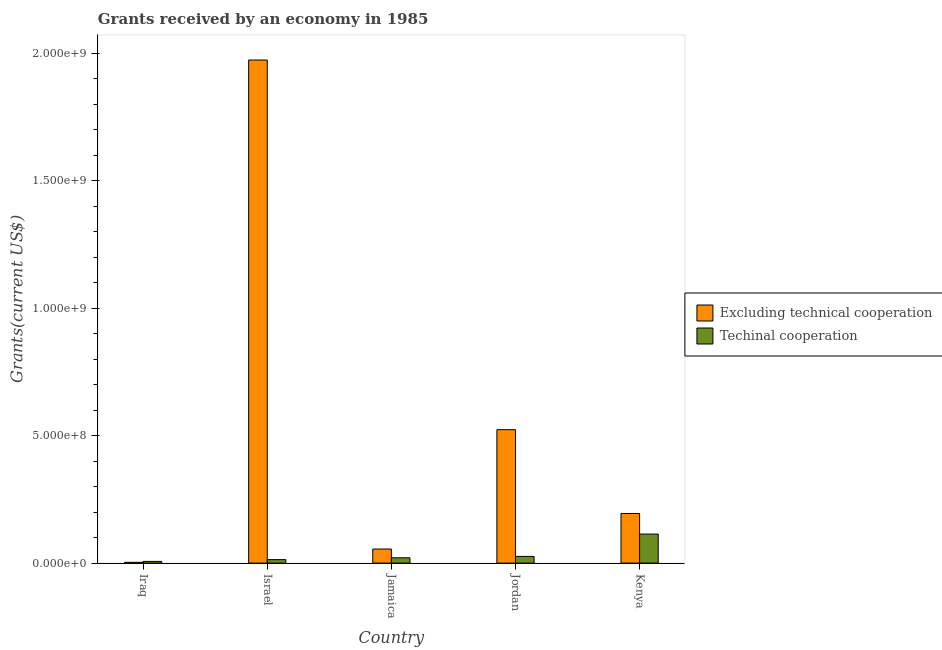How many different coloured bars are there?
Give a very brief answer. 2. What is the label of the 3rd group of bars from the left?
Make the answer very short. Jamaica. In how many cases, is the number of bars for a given country not equal to the number of legend labels?
Offer a terse response. 0. What is the amount of grants received(excluding technical cooperation) in Iraq?
Your answer should be compact. 3.13e+06. Across all countries, what is the maximum amount of grants received(excluding technical cooperation)?
Keep it short and to the point. 1.97e+09. Across all countries, what is the minimum amount of grants received(including technical cooperation)?
Provide a short and direct response. 6.67e+06. In which country was the amount of grants received(including technical cooperation) maximum?
Offer a terse response. Kenya. In which country was the amount of grants received(including technical cooperation) minimum?
Your answer should be compact. Iraq. What is the total amount of grants received(including technical cooperation) in the graph?
Make the answer very short. 1.81e+08. What is the difference between the amount of grants received(excluding technical cooperation) in Israel and that in Jordan?
Give a very brief answer. 1.45e+09. What is the difference between the amount of grants received(including technical cooperation) in Iraq and the amount of grants received(excluding technical cooperation) in Jordan?
Give a very brief answer. -5.17e+08. What is the average amount of grants received(including technical cooperation) per country?
Your response must be concise. 3.62e+07. What is the difference between the amount of grants received(including technical cooperation) and amount of grants received(excluding technical cooperation) in Jamaica?
Your answer should be compact. -3.43e+07. What is the ratio of the amount of grants received(excluding technical cooperation) in Jordan to that in Kenya?
Provide a succinct answer. 2.69. What is the difference between the highest and the second highest amount of grants received(including technical cooperation)?
Provide a short and direct response. 8.76e+07. What is the difference between the highest and the lowest amount of grants received(including technical cooperation)?
Offer a terse response. 1.07e+08. Is the sum of the amount of grants received(excluding technical cooperation) in Iraq and Israel greater than the maximum amount of grants received(including technical cooperation) across all countries?
Offer a very short reply. Yes. What does the 2nd bar from the left in Jamaica represents?
Keep it short and to the point. Techinal cooperation. What does the 1st bar from the right in Jordan represents?
Your answer should be compact. Techinal cooperation. What is the difference between two consecutive major ticks on the Y-axis?
Give a very brief answer. 5.00e+08. Are the values on the major ticks of Y-axis written in scientific E-notation?
Offer a very short reply. Yes. Does the graph contain grids?
Provide a succinct answer. No. How are the legend labels stacked?
Offer a very short reply. Vertical. What is the title of the graph?
Provide a succinct answer. Grants received by an economy in 1985. What is the label or title of the X-axis?
Your answer should be compact. Country. What is the label or title of the Y-axis?
Your response must be concise. Grants(current US$). What is the Grants(current US$) of Excluding technical cooperation in Iraq?
Offer a very short reply. 3.13e+06. What is the Grants(current US$) in Techinal cooperation in Iraq?
Give a very brief answer. 6.67e+06. What is the Grants(current US$) of Excluding technical cooperation in Israel?
Provide a succinct answer. 1.97e+09. What is the Grants(current US$) in Techinal cooperation in Israel?
Give a very brief answer. 1.36e+07. What is the Grants(current US$) in Excluding technical cooperation in Jamaica?
Give a very brief answer. 5.51e+07. What is the Grants(current US$) of Techinal cooperation in Jamaica?
Your answer should be very brief. 2.08e+07. What is the Grants(current US$) of Excluding technical cooperation in Jordan?
Keep it short and to the point. 5.23e+08. What is the Grants(current US$) of Techinal cooperation in Jordan?
Your answer should be very brief. 2.62e+07. What is the Grants(current US$) of Excluding technical cooperation in Kenya?
Offer a terse response. 1.95e+08. What is the Grants(current US$) in Techinal cooperation in Kenya?
Make the answer very short. 1.14e+08. Across all countries, what is the maximum Grants(current US$) of Excluding technical cooperation?
Your answer should be very brief. 1.97e+09. Across all countries, what is the maximum Grants(current US$) in Techinal cooperation?
Provide a succinct answer. 1.14e+08. Across all countries, what is the minimum Grants(current US$) in Excluding technical cooperation?
Ensure brevity in your answer.  3.13e+06. Across all countries, what is the minimum Grants(current US$) in Techinal cooperation?
Offer a very short reply. 6.67e+06. What is the total Grants(current US$) in Excluding technical cooperation in the graph?
Offer a terse response. 2.75e+09. What is the total Grants(current US$) in Techinal cooperation in the graph?
Keep it short and to the point. 1.81e+08. What is the difference between the Grants(current US$) of Excluding technical cooperation in Iraq and that in Israel?
Ensure brevity in your answer.  -1.97e+09. What is the difference between the Grants(current US$) in Techinal cooperation in Iraq and that in Israel?
Offer a very short reply. -6.94e+06. What is the difference between the Grants(current US$) of Excluding technical cooperation in Iraq and that in Jamaica?
Provide a short and direct response. -5.20e+07. What is the difference between the Grants(current US$) of Techinal cooperation in Iraq and that in Jamaica?
Make the answer very short. -1.41e+07. What is the difference between the Grants(current US$) of Excluding technical cooperation in Iraq and that in Jordan?
Keep it short and to the point. -5.20e+08. What is the difference between the Grants(current US$) in Techinal cooperation in Iraq and that in Jordan?
Your answer should be very brief. -1.95e+07. What is the difference between the Grants(current US$) of Excluding technical cooperation in Iraq and that in Kenya?
Your answer should be very brief. -1.91e+08. What is the difference between the Grants(current US$) in Techinal cooperation in Iraq and that in Kenya?
Give a very brief answer. -1.07e+08. What is the difference between the Grants(current US$) in Excluding technical cooperation in Israel and that in Jamaica?
Ensure brevity in your answer.  1.92e+09. What is the difference between the Grants(current US$) of Techinal cooperation in Israel and that in Jamaica?
Your response must be concise. -7.19e+06. What is the difference between the Grants(current US$) of Excluding technical cooperation in Israel and that in Jordan?
Give a very brief answer. 1.45e+09. What is the difference between the Grants(current US$) in Techinal cooperation in Israel and that in Jordan?
Give a very brief answer. -1.26e+07. What is the difference between the Grants(current US$) of Excluding technical cooperation in Israel and that in Kenya?
Give a very brief answer. 1.78e+09. What is the difference between the Grants(current US$) in Techinal cooperation in Israel and that in Kenya?
Keep it short and to the point. -1.00e+08. What is the difference between the Grants(current US$) in Excluding technical cooperation in Jamaica and that in Jordan?
Provide a short and direct response. -4.68e+08. What is the difference between the Grants(current US$) of Techinal cooperation in Jamaica and that in Jordan?
Offer a very short reply. -5.40e+06. What is the difference between the Grants(current US$) of Excluding technical cooperation in Jamaica and that in Kenya?
Offer a terse response. -1.39e+08. What is the difference between the Grants(current US$) in Techinal cooperation in Jamaica and that in Kenya?
Give a very brief answer. -9.30e+07. What is the difference between the Grants(current US$) in Excluding technical cooperation in Jordan and that in Kenya?
Your answer should be very brief. 3.29e+08. What is the difference between the Grants(current US$) of Techinal cooperation in Jordan and that in Kenya?
Your answer should be very brief. -8.76e+07. What is the difference between the Grants(current US$) of Excluding technical cooperation in Iraq and the Grants(current US$) of Techinal cooperation in Israel?
Give a very brief answer. -1.05e+07. What is the difference between the Grants(current US$) of Excluding technical cooperation in Iraq and the Grants(current US$) of Techinal cooperation in Jamaica?
Your answer should be very brief. -1.77e+07. What is the difference between the Grants(current US$) in Excluding technical cooperation in Iraq and the Grants(current US$) in Techinal cooperation in Jordan?
Your response must be concise. -2.31e+07. What is the difference between the Grants(current US$) in Excluding technical cooperation in Iraq and the Grants(current US$) in Techinal cooperation in Kenya?
Provide a succinct answer. -1.11e+08. What is the difference between the Grants(current US$) in Excluding technical cooperation in Israel and the Grants(current US$) in Techinal cooperation in Jamaica?
Offer a terse response. 1.95e+09. What is the difference between the Grants(current US$) of Excluding technical cooperation in Israel and the Grants(current US$) of Techinal cooperation in Jordan?
Offer a terse response. 1.95e+09. What is the difference between the Grants(current US$) of Excluding technical cooperation in Israel and the Grants(current US$) of Techinal cooperation in Kenya?
Give a very brief answer. 1.86e+09. What is the difference between the Grants(current US$) in Excluding technical cooperation in Jamaica and the Grants(current US$) in Techinal cooperation in Jordan?
Give a very brief answer. 2.89e+07. What is the difference between the Grants(current US$) in Excluding technical cooperation in Jamaica and the Grants(current US$) in Techinal cooperation in Kenya?
Offer a very short reply. -5.87e+07. What is the difference between the Grants(current US$) in Excluding technical cooperation in Jordan and the Grants(current US$) in Techinal cooperation in Kenya?
Your response must be concise. 4.09e+08. What is the average Grants(current US$) in Excluding technical cooperation per country?
Ensure brevity in your answer.  5.50e+08. What is the average Grants(current US$) in Techinal cooperation per country?
Give a very brief answer. 3.62e+07. What is the difference between the Grants(current US$) of Excluding technical cooperation and Grants(current US$) of Techinal cooperation in Iraq?
Keep it short and to the point. -3.54e+06. What is the difference between the Grants(current US$) in Excluding technical cooperation and Grants(current US$) in Techinal cooperation in Israel?
Your response must be concise. 1.96e+09. What is the difference between the Grants(current US$) in Excluding technical cooperation and Grants(current US$) in Techinal cooperation in Jamaica?
Keep it short and to the point. 3.43e+07. What is the difference between the Grants(current US$) in Excluding technical cooperation and Grants(current US$) in Techinal cooperation in Jordan?
Your response must be concise. 4.97e+08. What is the difference between the Grants(current US$) of Excluding technical cooperation and Grants(current US$) of Techinal cooperation in Kenya?
Keep it short and to the point. 8.08e+07. What is the ratio of the Grants(current US$) of Excluding technical cooperation in Iraq to that in Israel?
Provide a succinct answer. 0. What is the ratio of the Grants(current US$) in Techinal cooperation in Iraq to that in Israel?
Your answer should be compact. 0.49. What is the ratio of the Grants(current US$) in Excluding technical cooperation in Iraq to that in Jamaica?
Provide a short and direct response. 0.06. What is the ratio of the Grants(current US$) of Techinal cooperation in Iraq to that in Jamaica?
Your answer should be compact. 0.32. What is the ratio of the Grants(current US$) in Excluding technical cooperation in Iraq to that in Jordan?
Provide a short and direct response. 0.01. What is the ratio of the Grants(current US$) of Techinal cooperation in Iraq to that in Jordan?
Your answer should be very brief. 0.25. What is the ratio of the Grants(current US$) of Excluding technical cooperation in Iraq to that in Kenya?
Your answer should be compact. 0.02. What is the ratio of the Grants(current US$) of Techinal cooperation in Iraq to that in Kenya?
Give a very brief answer. 0.06. What is the ratio of the Grants(current US$) of Excluding technical cooperation in Israel to that in Jamaica?
Your answer should be compact. 35.79. What is the ratio of the Grants(current US$) of Techinal cooperation in Israel to that in Jamaica?
Offer a terse response. 0.65. What is the ratio of the Grants(current US$) of Excluding technical cooperation in Israel to that in Jordan?
Your answer should be compact. 3.77. What is the ratio of the Grants(current US$) of Techinal cooperation in Israel to that in Jordan?
Your answer should be compact. 0.52. What is the ratio of the Grants(current US$) of Excluding technical cooperation in Israel to that in Kenya?
Ensure brevity in your answer.  10.14. What is the ratio of the Grants(current US$) of Techinal cooperation in Israel to that in Kenya?
Offer a terse response. 0.12. What is the ratio of the Grants(current US$) of Excluding technical cooperation in Jamaica to that in Jordan?
Your response must be concise. 0.11. What is the ratio of the Grants(current US$) in Techinal cooperation in Jamaica to that in Jordan?
Your answer should be compact. 0.79. What is the ratio of the Grants(current US$) of Excluding technical cooperation in Jamaica to that in Kenya?
Keep it short and to the point. 0.28. What is the ratio of the Grants(current US$) of Techinal cooperation in Jamaica to that in Kenya?
Your answer should be very brief. 0.18. What is the ratio of the Grants(current US$) in Excluding technical cooperation in Jordan to that in Kenya?
Make the answer very short. 2.69. What is the ratio of the Grants(current US$) in Techinal cooperation in Jordan to that in Kenya?
Give a very brief answer. 0.23. What is the difference between the highest and the second highest Grants(current US$) in Excluding technical cooperation?
Make the answer very short. 1.45e+09. What is the difference between the highest and the second highest Grants(current US$) in Techinal cooperation?
Ensure brevity in your answer.  8.76e+07. What is the difference between the highest and the lowest Grants(current US$) of Excluding technical cooperation?
Offer a very short reply. 1.97e+09. What is the difference between the highest and the lowest Grants(current US$) in Techinal cooperation?
Provide a short and direct response. 1.07e+08. 